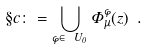Convert formula to latex. <formula><loc_0><loc_0><loc_500><loc_500>\S c \colon = \bigcup _ { \varphi \in \ U _ { 0 } } \Phi _ { \mu } ^ { \varphi } ( z ) \ .</formula> 